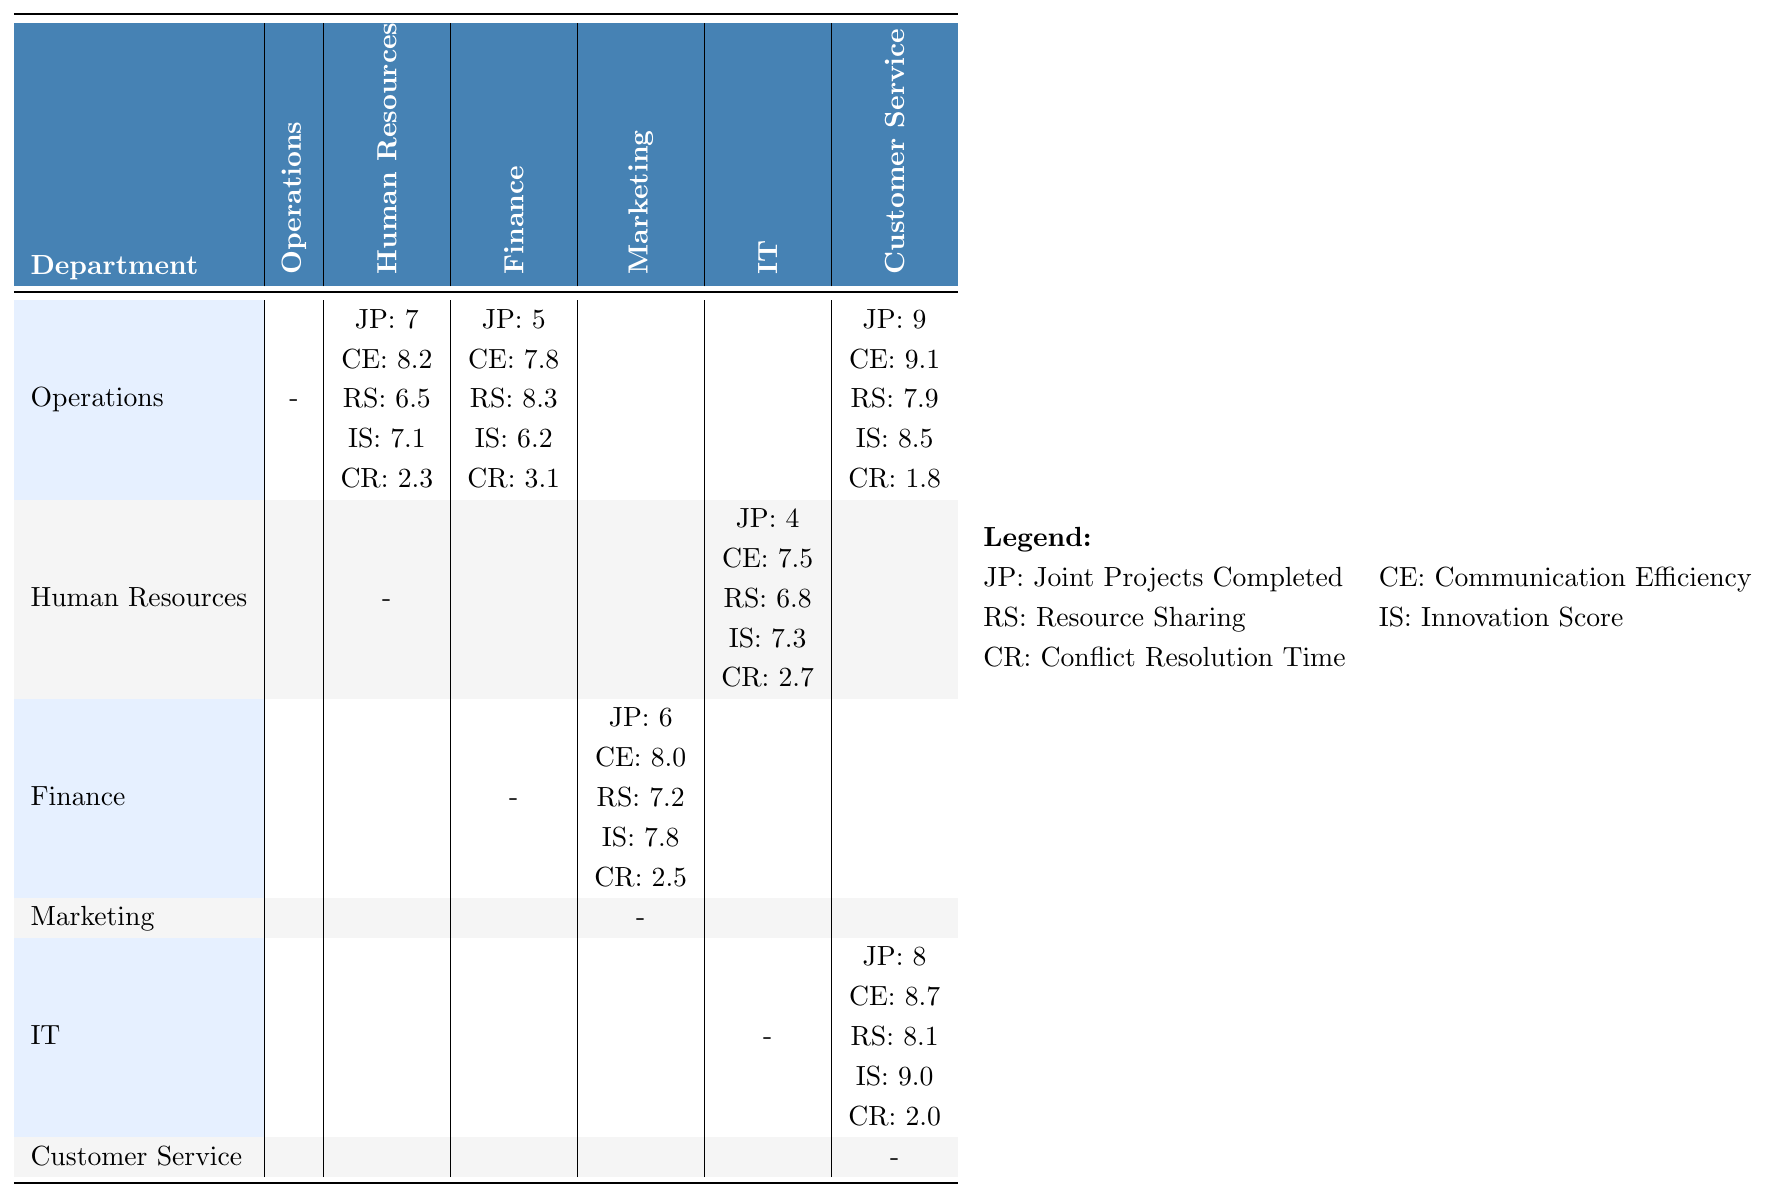What is the Joint Projects Completed between Operations and Customer Service? The table indicates that Operations and Customer Service completed 9 Joint Projects.
Answer: 9 What is the Communication Efficiency score for Human Resources when collaborating with IT? The table shows that the Communication Efficiency score for Human Resources collaborating with IT is 7.5.
Answer: 7.5 Which department has the highest Innovation Score? The highest Innovation Score is from IT at 9.0.
Answer: IT What is the average Resource Sharing score for all collaborations? The Resource Sharing scores are 6.5, 8.3, 7.9, 6.8, 7.2, and 8.1. The average is calculated as (6.5 + 8.3 + 7.9 + 6.8 + 7.2 + 8.1) / 6 = 7.5.
Answer: 7.5 Is the Conflict Resolution Time better between Operations and Human Resources compared to Operations and Finance? The Conflict Resolution Time for Operations and Human Resources is 2.3, while for Operations and Finance it is 3.1. Since 2.3 is less than 3.1, it is better.
Answer: Yes How does the Communication Efficiency score of IT comparing to Customer Service? IT has a Communication Efficiency score of 8.7 while Customer Service’s score is not directly shown with IT, but with other departments, thus residing 8.7 as the efficiency score being better.
Answer: IT has a higher score Which two departments show the fastest Conflict Resolution Time? The fastest Conflict Resolution Time is between Operations and Customer Service at 1.8 and Operations and Human Resources at 2.3. Comparing them, 1.8 is faster.
Answer: Operations and Customer Service What is the total number of Joint Projects Completed among all collaborations? The total number is the sum: 7 (HR) + 5 (Finance) + 9 (CS) + 4 (IT) + 6 (Marketing) + 8 (CS) = 39.
Answer: 39 Which department had the lowest Resource Sharing score during any collaboration? The lowest Resource Sharing score is 6.5 between Operations and Human Resources.
Answer: 6.5 What is the difference in Joint Projects Completed between Finance and Marketing? The Joint Projects Completed values are 6 for Finance and 0 for Marketing (no data). Thus, the difference is 6 - 0 = 6.
Answer: 6 